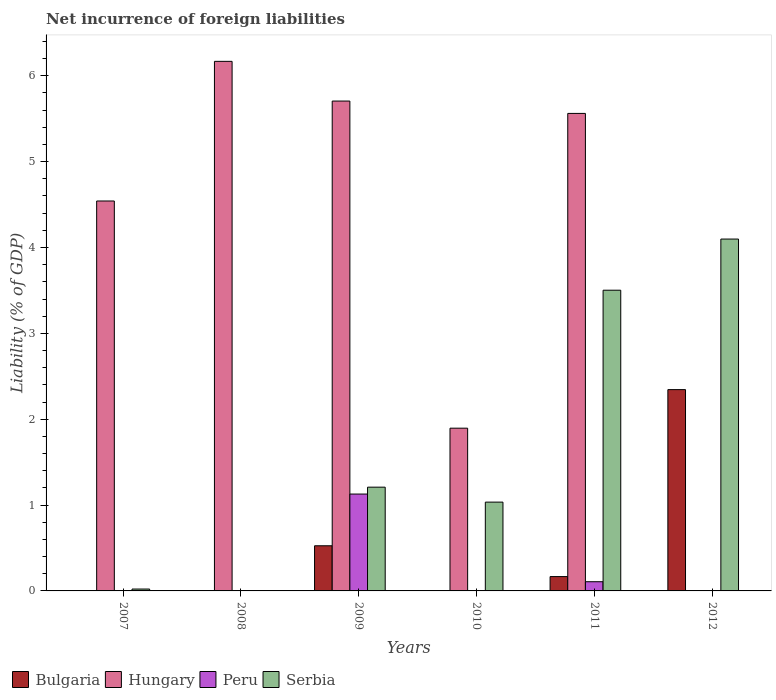How many different coloured bars are there?
Offer a terse response. 4. Are the number of bars per tick equal to the number of legend labels?
Keep it short and to the point. No. Are the number of bars on each tick of the X-axis equal?
Ensure brevity in your answer.  No. How many bars are there on the 1st tick from the left?
Offer a very short reply. 2. What is the net incurrence of foreign liabilities in Bulgaria in 2011?
Offer a very short reply. 0.17. Across all years, what is the maximum net incurrence of foreign liabilities in Hungary?
Keep it short and to the point. 6.17. What is the total net incurrence of foreign liabilities in Serbia in the graph?
Offer a terse response. 9.87. What is the difference between the net incurrence of foreign liabilities in Serbia in 2009 and that in 2011?
Give a very brief answer. -2.29. What is the difference between the net incurrence of foreign liabilities in Peru in 2011 and the net incurrence of foreign liabilities in Serbia in 2012?
Ensure brevity in your answer.  -3.99. What is the average net incurrence of foreign liabilities in Peru per year?
Ensure brevity in your answer.  0.21. In the year 2009, what is the difference between the net incurrence of foreign liabilities in Hungary and net incurrence of foreign liabilities in Bulgaria?
Offer a very short reply. 5.18. What is the ratio of the net incurrence of foreign liabilities in Hungary in 2009 to that in 2010?
Offer a very short reply. 3.01. What is the difference between the highest and the second highest net incurrence of foreign liabilities in Serbia?
Make the answer very short. 0.6. What is the difference between the highest and the lowest net incurrence of foreign liabilities in Bulgaria?
Provide a short and direct response. 2.34. In how many years, is the net incurrence of foreign liabilities in Hungary greater than the average net incurrence of foreign liabilities in Hungary taken over all years?
Make the answer very short. 4. Is it the case that in every year, the sum of the net incurrence of foreign liabilities in Serbia and net incurrence of foreign liabilities in Bulgaria is greater than the sum of net incurrence of foreign liabilities in Hungary and net incurrence of foreign liabilities in Peru?
Keep it short and to the point. No. Are all the bars in the graph horizontal?
Provide a short and direct response. No. What is the difference between two consecutive major ticks on the Y-axis?
Ensure brevity in your answer.  1. Are the values on the major ticks of Y-axis written in scientific E-notation?
Your response must be concise. No. Does the graph contain any zero values?
Ensure brevity in your answer.  Yes. Where does the legend appear in the graph?
Give a very brief answer. Bottom left. What is the title of the graph?
Your response must be concise. Net incurrence of foreign liabilities. Does "Tajikistan" appear as one of the legend labels in the graph?
Give a very brief answer. No. What is the label or title of the X-axis?
Your response must be concise. Years. What is the label or title of the Y-axis?
Your answer should be very brief. Liability (% of GDP). What is the Liability (% of GDP) in Bulgaria in 2007?
Offer a terse response. 0. What is the Liability (% of GDP) of Hungary in 2007?
Ensure brevity in your answer.  4.54. What is the Liability (% of GDP) in Serbia in 2007?
Offer a terse response. 0.02. What is the Liability (% of GDP) in Hungary in 2008?
Provide a short and direct response. 6.17. What is the Liability (% of GDP) of Peru in 2008?
Ensure brevity in your answer.  0. What is the Liability (% of GDP) of Bulgaria in 2009?
Make the answer very short. 0.53. What is the Liability (% of GDP) of Hungary in 2009?
Offer a terse response. 5.71. What is the Liability (% of GDP) of Peru in 2009?
Your answer should be very brief. 1.13. What is the Liability (% of GDP) in Serbia in 2009?
Offer a terse response. 1.21. What is the Liability (% of GDP) in Bulgaria in 2010?
Keep it short and to the point. 0. What is the Liability (% of GDP) in Hungary in 2010?
Ensure brevity in your answer.  1.9. What is the Liability (% of GDP) of Serbia in 2010?
Ensure brevity in your answer.  1.03. What is the Liability (% of GDP) of Bulgaria in 2011?
Offer a very short reply. 0.17. What is the Liability (% of GDP) of Hungary in 2011?
Make the answer very short. 5.56. What is the Liability (% of GDP) in Peru in 2011?
Make the answer very short. 0.11. What is the Liability (% of GDP) in Serbia in 2011?
Your answer should be very brief. 3.5. What is the Liability (% of GDP) of Bulgaria in 2012?
Your answer should be very brief. 2.34. What is the Liability (% of GDP) of Serbia in 2012?
Your answer should be compact. 4.1. Across all years, what is the maximum Liability (% of GDP) in Bulgaria?
Keep it short and to the point. 2.34. Across all years, what is the maximum Liability (% of GDP) in Hungary?
Keep it short and to the point. 6.17. Across all years, what is the maximum Liability (% of GDP) of Peru?
Offer a terse response. 1.13. Across all years, what is the maximum Liability (% of GDP) in Serbia?
Make the answer very short. 4.1. Across all years, what is the minimum Liability (% of GDP) of Hungary?
Provide a short and direct response. 0. What is the total Liability (% of GDP) in Bulgaria in the graph?
Keep it short and to the point. 3.04. What is the total Liability (% of GDP) in Hungary in the graph?
Make the answer very short. 23.87. What is the total Liability (% of GDP) of Peru in the graph?
Make the answer very short. 1.24. What is the total Liability (% of GDP) in Serbia in the graph?
Provide a short and direct response. 9.87. What is the difference between the Liability (% of GDP) of Hungary in 2007 and that in 2008?
Give a very brief answer. -1.63. What is the difference between the Liability (% of GDP) in Hungary in 2007 and that in 2009?
Your response must be concise. -1.16. What is the difference between the Liability (% of GDP) of Serbia in 2007 and that in 2009?
Keep it short and to the point. -1.19. What is the difference between the Liability (% of GDP) in Hungary in 2007 and that in 2010?
Keep it short and to the point. 2.65. What is the difference between the Liability (% of GDP) in Serbia in 2007 and that in 2010?
Ensure brevity in your answer.  -1.01. What is the difference between the Liability (% of GDP) in Hungary in 2007 and that in 2011?
Your answer should be very brief. -1.02. What is the difference between the Liability (% of GDP) in Serbia in 2007 and that in 2011?
Provide a succinct answer. -3.48. What is the difference between the Liability (% of GDP) in Serbia in 2007 and that in 2012?
Give a very brief answer. -4.08. What is the difference between the Liability (% of GDP) of Hungary in 2008 and that in 2009?
Keep it short and to the point. 0.46. What is the difference between the Liability (% of GDP) in Hungary in 2008 and that in 2010?
Your answer should be compact. 4.27. What is the difference between the Liability (% of GDP) in Hungary in 2008 and that in 2011?
Provide a short and direct response. 0.61. What is the difference between the Liability (% of GDP) in Hungary in 2009 and that in 2010?
Offer a very short reply. 3.81. What is the difference between the Liability (% of GDP) in Serbia in 2009 and that in 2010?
Make the answer very short. 0.17. What is the difference between the Liability (% of GDP) of Bulgaria in 2009 and that in 2011?
Make the answer very short. 0.36. What is the difference between the Liability (% of GDP) in Hungary in 2009 and that in 2011?
Keep it short and to the point. 0.14. What is the difference between the Liability (% of GDP) of Peru in 2009 and that in 2011?
Provide a succinct answer. 1.02. What is the difference between the Liability (% of GDP) in Serbia in 2009 and that in 2011?
Make the answer very short. -2.29. What is the difference between the Liability (% of GDP) in Bulgaria in 2009 and that in 2012?
Offer a very short reply. -1.82. What is the difference between the Liability (% of GDP) of Serbia in 2009 and that in 2012?
Your response must be concise. -2.89. What is the difference between the Liability (% of GDP) of Hungary in 2010 and that in 2011?
Provide a succinct answer. -3.67. What is the difference between the Liability (% of GDP) of Serbia in 2010 and that in 2011?
Your answer should be compact. -2.47. What is the difference between the Liability (% of GDP) in Serbia in 2010 and that in 2012?
Ensure brevity in your answer.  -3.06. What is the difference between the Liability (% of GDP) of Bulgaria in 2011 and that in 2012?
Give a very brief answer. -2.18. What is the difference between the Liability (% of GDP) of Serbia in 2011 and that in 2012?
Your answer should be compact. -0.6. What is the difference between the Liability (% of GDP) of Hungary in 2007 and the Liability (% of GDP) of Peru in 2009?
Give a very brief answer. 3.41. What is the difference between the Liability (% of GDP) in Hungary in 2007 and the Liability (% of GDP) in Serbia in 2009?
Offer a terse response. 3.33. What is the difference between the Liability (% of GDP) in Hungary in 2007 and the Liability (% of GDP) in Serbia in 2010?
Provide a succinct answer. 3.51. What is the difference between the Liability (% of GDP) of Hungary in 2007 and the Liability (% of GDP) of Peru in 2011?
Your answer should be compact. 4.43. What is the difference between the Liability (% of GDP) in Hungary in 2007 and the Liability (% of GDP) in Serbia in 2011?
Ensure brevity in your answer.  1.04. What is the difference between the Liability (% of GDP) of Hungary in 2007 and the Liability (% of GDP) of Serbia in 2012?
Give a very brief answer. 0.44. What is the difference between the Liability (% of GDP) in Hungary in 2008 and the Liability (% of GDP) in Peru in 2009?
Offer a very short reply. 5.04. What is the difference between the Liability (% of GDP) in Hungary in 2008 and the Liability (% of GDP) in Serbia in 2009?
Your answer should be compact. 4.96. What is the difference between the Liability (% of GDP) of Hungary in 2008 and the Liability (% of GDP) of Serbia in 2010?
Your response must be concise. 5.13. What is the difference between the Liability (% of GDP) of Hungary in 2008 and the Liability (% of GDP) of Peru in 2011?
Make the answer very short. 6.06. What is the difference between the Liability (% of GDP) of Hungary in 2008 and the Liability (% of GDP) of Serbia in 2011?
Provide a succinct answer. 2.67. What is the difference between the Liability (% of GDP) in Hungary in 2008 and the Liability (% of GDP) in Serbia in 2012?
Make the answer very short. 2.07. What is the difference between the Liability (% of GDP) in Bulgaria in 2009 and the Liability (% of GDP) in Hungary in 2010?
Your answer should be very brief. -1.37. What is the difference between the Liability (% of GDP) in Bulgaria in 2009 and the Liability (% of GDP) in Serbia in 2010?
Make the answer very short. -0.51. What is the difference between the Liability (% of GDP) in Hungary in 2009 and the Liability (% of GDP) in Serbia in 2010?
Your response must be concise. 4.67. What is the difference between the Liability (% of GDP) in Peru in 2009 and the Liability (% of GDP) in Serbia in 2010?
Give a very brief answer. 0.09. What is the difference between the Liability (% of GDP) of Bulgaria in 2009 and the Liability (% of GDP) of Hungary in 2011?
Keep it short and to the point. -5.04. What is the difference between the Liability (% of GDP) of Bulgaria in 2009 and the Liability (% of GDP) of Peru in 2011?
Your response must be concise. 0.42. What is the difference between the Liability (% of GDP) in Bulgaria in 2009 and the Liability (% of GDP) in Serbia in 2011?
Give a very brief answer. -2.98. What is the difference between the Liability (% of GDP) in Hungary in 2009 and the Liability (% of GDP) in Peru in 2011?
Ensure brevity in your answer.  5.6. What is the difference between the Liability (% of GDP) of Hungary in 2009 and the Liability (% of GDP) of Serbia in 2011?
Provide a succinct answer. 2.2. What is the difference between the Liability (% of GDP) of Peru in 2009 and the Liability (% of GDP) of Serbia in 2011?
Ensure brevity in your answer.  -2.37. What is the difference between the Liability (% of GDP) in Bulgaria in 2009 and the Liability (% of GDP) in Serbia in 2012?
Your answer should be very brief. -3.57. What is the difference between the Liability (% of GDP) of Hungary in 2009 and the Liability (% of GDP) of Serbia in 2012?
Give a very brief answer. 1.61. What is the difference between the Liability (% of GDP) in Peru in 2009 and the Liability (% of GDP) in Serbia in 2012?
Offer a very short reply. -2.97. What is the difference between the Liability (% of GDP) in Hungary in 2010 and the Liability (% of GDP) in Peru in 2011?
Offer a terse response. 1.79. What is the difference between the Liability (% of GDP) of Hungary in 2010 and the Liability (% of GDP) of Serbia in 2011?
Your response must be concise. -1.61. What is the difference between the Liability (% of GDP) of Hungary in 2010 and the Liability (% of GDP) of Serbia in 2012?
Your answer should be compact. -2.2. What is the difference between the Liability (% of GDP) in Bulgaria in 2011 and the Liability (% of GDP) in Serbia in 2012?
Provide a short and direct response. -3.93. What is the difference between the Liability (% of GDP) of Hungary in 2011 and the Liability (% of GDP) of Serbia in 2012?
Your answer should be very brief. 1.46. What is the difference between the Liability (% of GDP) in Peru in 2011 and the Liability (% of GDP) in Serbia in 2012?
Keep it short and to the point. -3.99. What is the average Liability (% of GDP) in Bulgaria per year?
Your answer should be very brief. 0.51. What is the average Liability (% of GDP) of Hungary per year?
Ensure brevity in your answer.  3.98. What is the average Liability (% of GDP) in Peru per year?
Keep it short and to the point. 0.21. What is the average Liability (% of GDP) of Serbia per year?
Provide a short and direct response. 1.64. In the year 2007, what is the difference between the Liability (% of GDP) in Hungary and Liability (% of GDP) in Serbia?
Provide a short and direct response. 4.52. In the year 2009, what is the difference between the Liability (% of GDP) in Bulgaria and Liability (% of GDP) in Hungary?
Provide a short and direct response. -5.18. In the year 2009, what is the difference between the Liability (% of GDP) of Bulgaria and Liability (% of GDP) of Peru?
Provide a succinct answer. -0.6. In the year 2009, what is the difference between the Liability (% of GDP) of Bulgaria and Liability (% of GDP) of Serbia?
Make the answer very short. -0.68. In the year 2009, what is the difference between the Liability (% of GDP) of Hungary and Liability (% of GDP) of Peru?
Provide a short and direct response. 4.58. In the year 2009, what is the difference between the Liability (% of GDP) of Hungary and Liability (% of GDP) of Serbia?
Your answer should be very brief. 4.5. In the year 2009, what is the difference between the Liability (% of GDP) in Peru and Liability (% of GDP) in Serbia?
Ensure brevity in your answer.  -0.08. In the year 2010, what is the difference between the Liability (% of GDP) in Hungary and Liability (% of GDP) in Serbia?
Your response must be concise. 0.86. In the year 2011, what is the difference between the Liability (% of GDP) in Bulgaria and Liability (% of GDP) in Hungary?
Keep it short and to the point. -5.39. In the year 2011, what is the difference between the Liability (% of GDP) in Bulgaria and Liability (% of GDP) in Peru?
Your response must be concise. 0.06. In the year 2011, what is the difference between the Liability (% of GDP) in Bulgaria and Liability (% of GDP) in Serbia?
Your response must be concise. -3.34. In the year 2011, what is the difference between the Liability (% of GDP) of Hungary and Liability (% of GDP) of Peru?
Give a very brief answer. 5.45. In the year 2011, what is the difference between the Liability (% of GDP) in Hungary and Liability (% of GDP) in Serbia?
Ensure brevity in your answer.  2.06. In the year 2011, what is the difference between the Liability (% of GDP) of Peru and Liability (% of GDP) of Serbia?
Keep it short and to the point. -3.4. In the year 2012, what is the difference between the Liability (% of GDP) in Bulgaria and Liability (% of GDP) in Serbia?
Keep it short and to the point. -1.75. What is the ratio of the Liability (% of GDP) of Hungary in 2007 to that in 2008?
Your response must be concise. 0.74. What is the ratio of the Liability (% of GDP) of Hungary in 2007 to that in 2009?
Offer a terse response. 0.8. What is the ratio of the Liability (% of GDP) of Serbia in 2007 to that in 2009?
Make the answer very short. 0.02. What is the ratio of the Liability (% of GDP) of Hungary in 2007 to that in 2010?
Provide a short and direct response. 2.4. What is the ratio of the Liability (% of GDP) in Serbia in 2007 to that in 2010?
Your response must be concise. 0.02. What is the ratio of the Liability (% of GDP) of Hungary in 2007 to that in 2011?
Provide a succinct answer. 0.82. What is the ratio of the Liability (% of GDP) of Serbia in 2007 to that in 2011?
Give a very brief answer. 0.01. What is the ratio of the Liability (% of GDP) in Serbia in 2007 to that in 2012?
Offer a terse response. 0.01. What is the ratio of the Liability (% of GDP) in Hungary in 2008 to that in 2009?
Give a very brief answer. 1.08. What is the ratio of the Liability (% of GDP) of Hungary in 2008 to that in 2010?
Offer a terse response. 3.25. What is the ratio of the Liability (% of GDP) of Hungary in 2008 to that in 2011?
Offer a terse response. 1.11. What is the ratio of the Liability (% of GDP) in Hungary in 2009 to that in 2010?
Your answer should be very brief. 3.01. What is the ratio of the Liability (% of GDP) in Serbia in 2009 to that in 2010?
Offer a very short reply. 1.17. What is the ratio of the Liability (% of GDP) of Bulgaria in 2009 to that in 2011?
Your answer should be very brief. 3.15. What is the ratio of the Liability (% of GDP) of Hungary in 2009 to that in 2011?
Provide a succinct answer. 1.03. What is the ratio of the Liability (% of GDP) in Peru in 2009 to that in 2011?
Offer a terse response. 10.54. What is the ratio of the Liability (% of GDP) of Serbia in 2009 to that in 2011?
Your response must be concise. 0.35. What is the ratio of the Liability (% of GDP) of Bulgaria in 2009 to that in 2012?
Offer a very short reply. 0.22. What is the ratio of the Liability (% of GDP) of Serbia in 2009 to that in 2012?
Give a very brief answer. 0.29. What is the ratio of the Liability (% of GDP) in Hungary in 2010 to that in 2011?
Offer a very short reply. 0.34. What is the ratio of the Liability (% of GDP) of Serbia in 2010 to that in 2011?
Your answer should be very brief. 0.3. What is the ratio of the Liability (% of GDP) of Serbia in 2010 to that in 2012?
Provide a succinct answer. 0.25. What is the ratio of the Liability (% of GDP) in Bulgaria in 2011 to that in 2012?
Give a very brief answer. 0.07. What is the ratio of the Liability (% of GDP) in Serbia in 2011 to that in 2012?
Give a very brief answer. 0.85. What is the difference between the highest and the second highest Liability (% of GDP) in Bulgaria?
Keep it short and to the point. 1.82. What is the difference between the highest and the second highest Liability (% of GDP) in Hungary?
Your answer should be very brief. 0.46. What is the difference between the highest and the second highest Liability (% of GDP) in Serbia?
Ensure brevity in your answer.  0.6. What is the difference between the highest and the lowest Liability (% of GDP) in Bulgaria?
Your answer should be compact. 2.34. What is the difference between the highest and the lowest Liability (% of GDP) in Hungary?
Ensure brevity in your answer.  6.17. What is the difference between the highest and the lowest Liability (% of GDP) of Peru?
Your answer should be very brief. 1.13. What is the difference between the highest and the lowest Liability (% of GDP) in Serbia?
Provide a succinct answer. 4.1. 